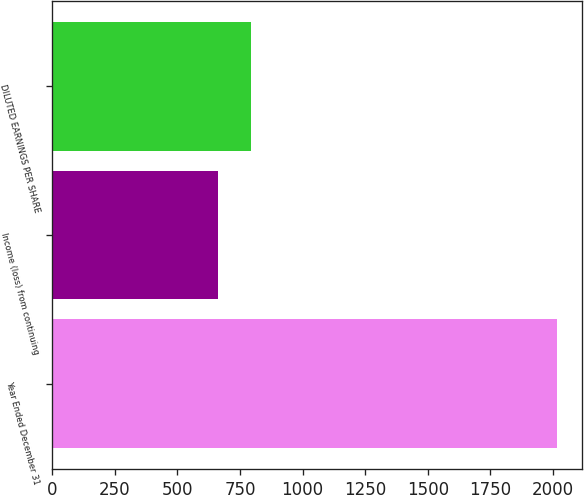Convert chart to OTSL. <chart><loc_0><loc_0><loc_500><loc_500><bar_chart><fcel>Year Ended December 31<fcel>Income (loss) from continuing<fcel>DILUTED EARNINGS PER SHARE<nl><fcel>2016<fcel>660<fcel>795.6<nl></chart> 